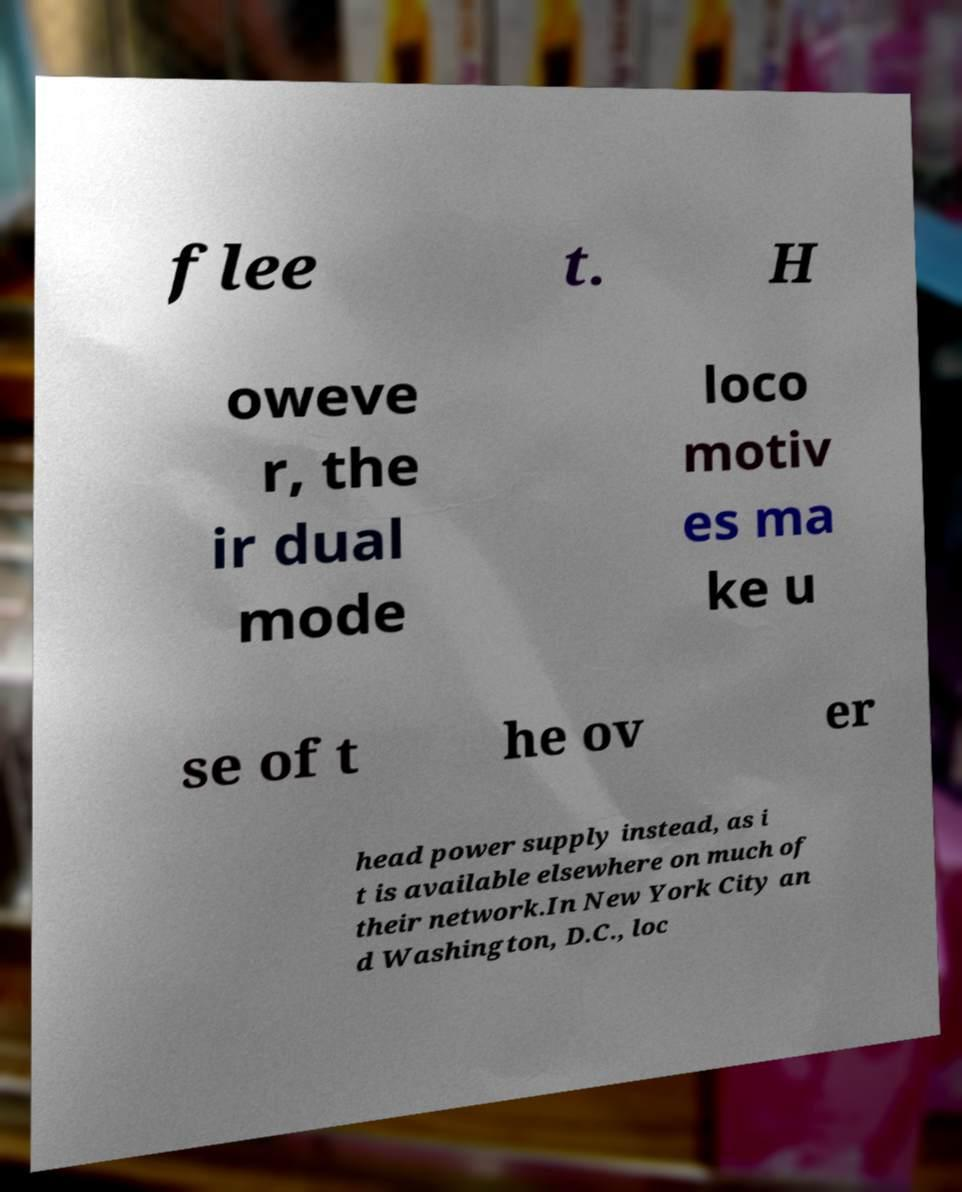For documentation purposes, I need the text within this image transcribed. Could you provide that? flee t. H oweve r, the ir dual mode loco motiv es ma ke u se of t he ov er head power supply instead, as i t is available elsewhere on much of their network.In New York City an d Washington, D.C., loc 